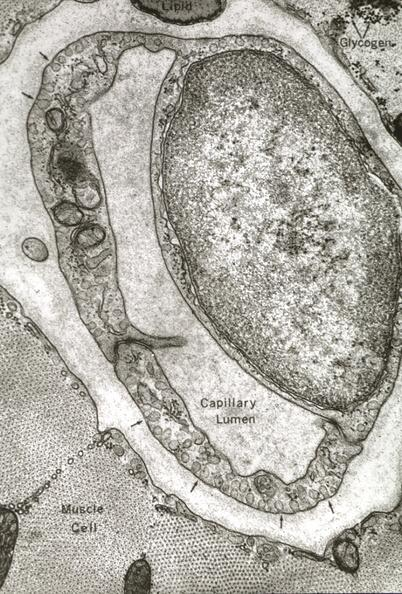does this image show skeletal muscle?
Answer the question using a single word or phrase. Yes 